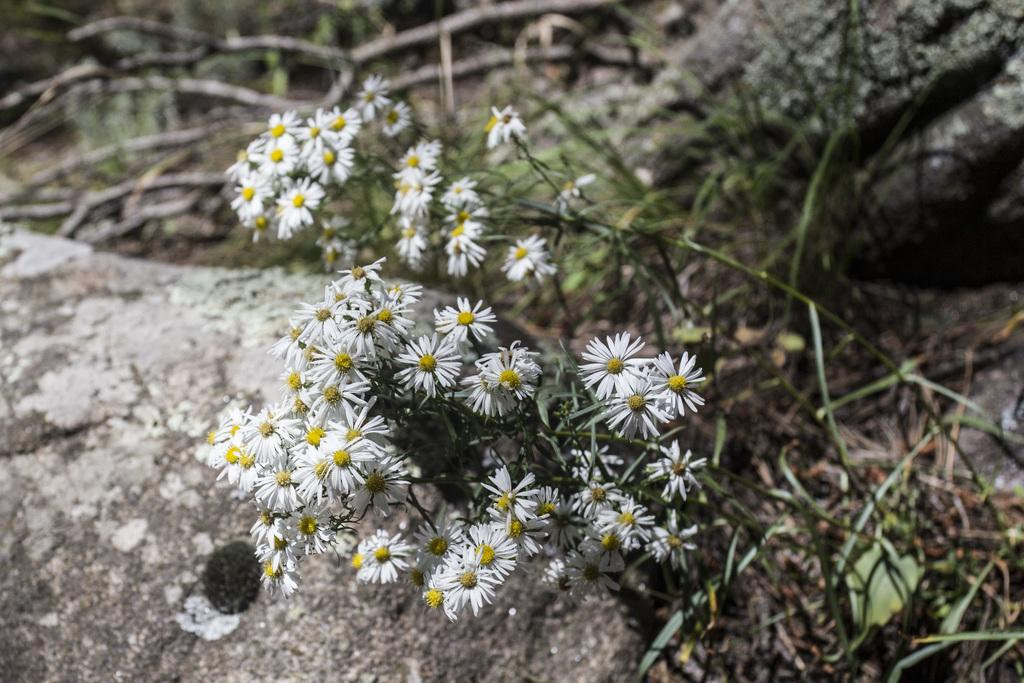What type of living organism is present in the image? There is a plant in the image. What are the main features of the plant? The plant has leaves and flowers. What color are the flowers on the plant? The flowers are white in color. What type of basin is being offered by the woman in the image? There is no woman or basin present in the image; it features a plant with white flowers. 